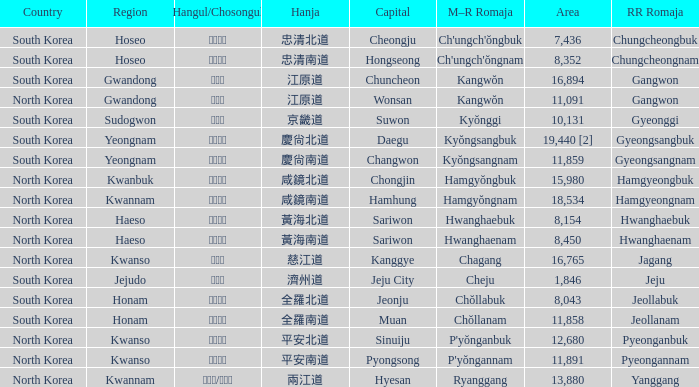What is the M-R Romaja for the province having a capital of Cheongju? Ch'ungch'ŏngbuk. 